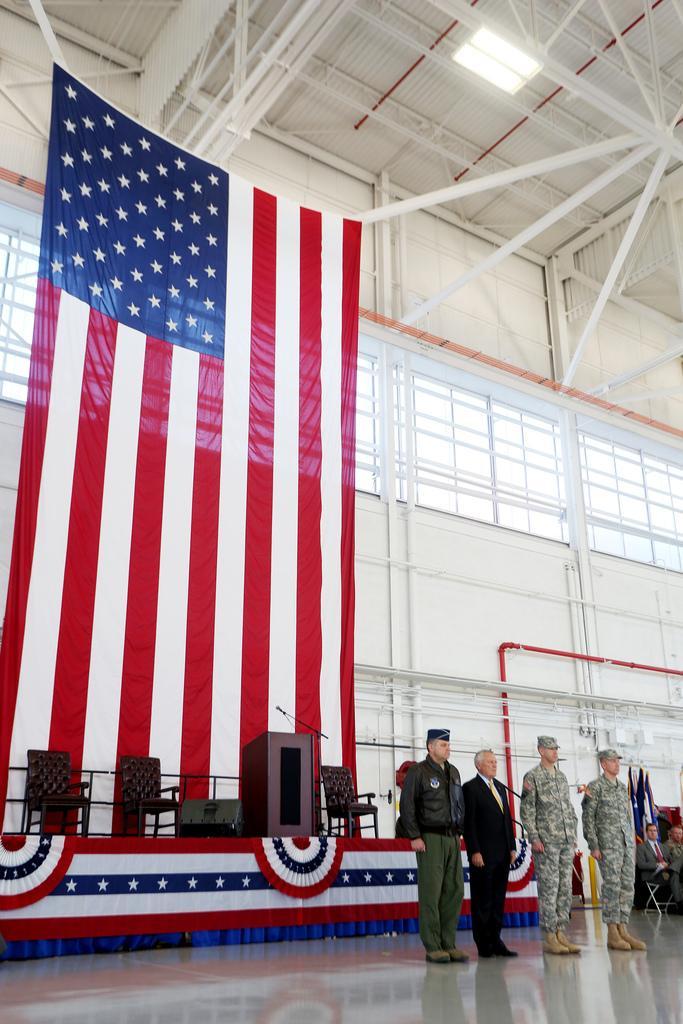Could you give a brief overview of what you see in this image? There is a group of persons standing as we can see at the bottom of this image. We can see a wall in the background. There is a flag on the left side of this image. 